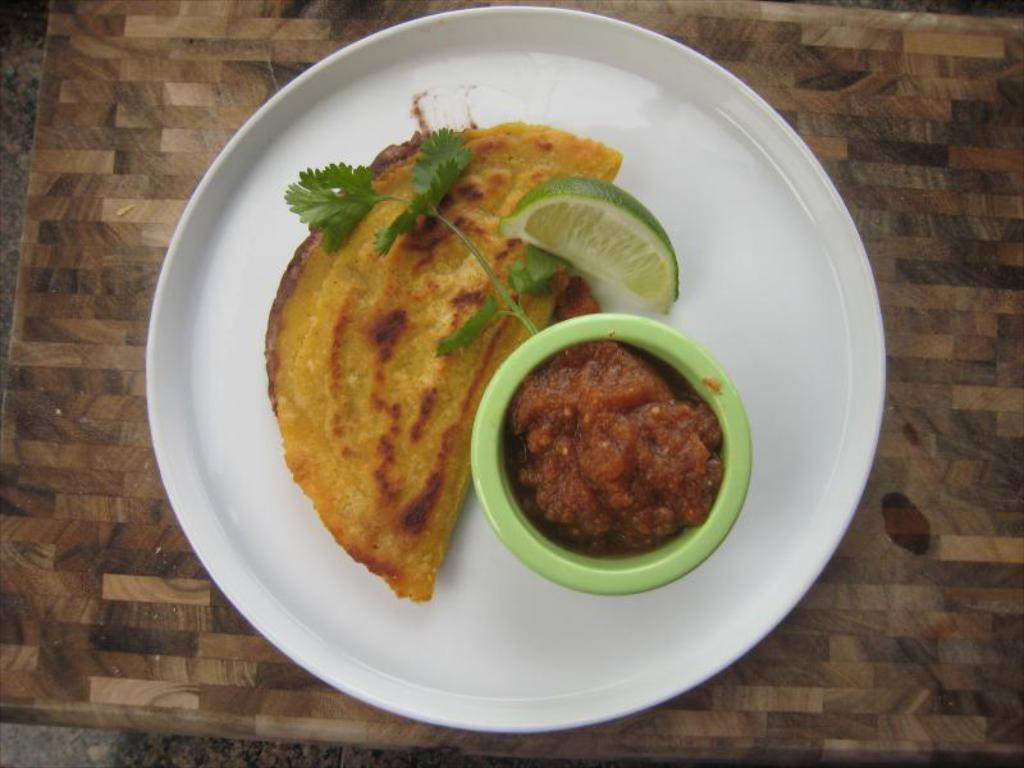What type of food item is visible in the image? There is a food item in the image, but the specific type is not mentioned. What citrus fruit is present in the image? There is a lemon in the image. What accompanies the food item and lemon on the plate? There is sauce in the image. Where is the plate with the food item, lemon, and sauce located? The plate is placed on a table. What type of growth can be seen on the hook in the image? There is no hook present in the image. What color is the sky in the image? The provided facts do not mention the sky, so we cannot determine its color. 